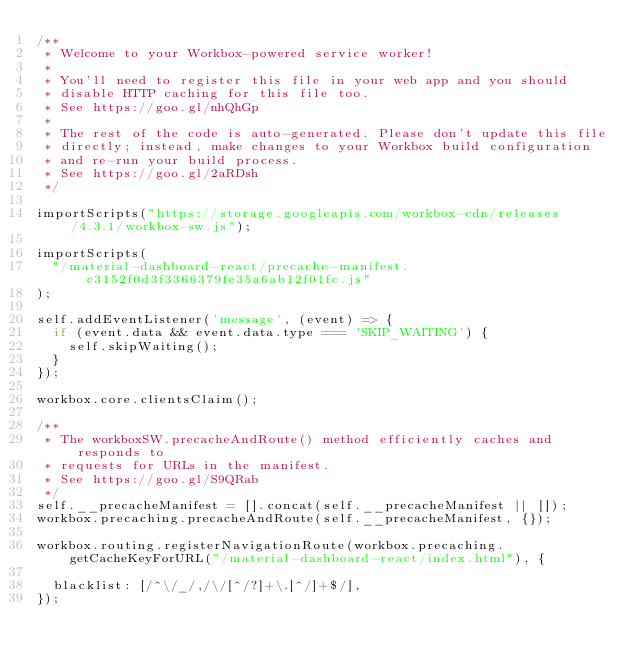<code> <loc_0><loc_0><loc_500><loc_500><_JavaScript_>/**
 * Welcome to your Workbox-powered service worker!
 *
 * You'll need to register this file in your web app and you should
 * disable HTTP caching for this file too.
 * See https://goo.gl/nhQhGp
 *
 * The rest of the code is auto-generated. Please don't update this file
 * directly; instead, make changes to your Workbox build configuration
 * and re-run your build process.
 * See https://goo.gl/2aRDsh
 */

importScripts("https://storage.googleapis.com/workbox-cdn/releases/4.3.1/workbox-sw.js");

importScripts(
  "/material-dashboard-react/precache-manifest.c3152f0d3f3366379fe35a6ab12f01fc.js"
);

self.addEventListener('message', (event) => {
  if (event.data && event.data.type === 'SKIP_WAITING') {
    self.skipWaiting();
  }
});

workbox.core.clientsClaim();

/**
 * The workboxSW.precacheAndRoute() method efficiently caches and responds to
 * requests for URLs in the manifest.
 * See https://goo.gl/S9QRab
 */
self.__precacheManifest = [].concat(self.__precacheManifest || []);
workbox.precaching.precacheAndRoute(self.__precacheManifest, {});

workbox.routing.registerNavigationRoute(workbox.precaching.getCacheKeyForURL("/material-dashboard-react/index.html"), {
  
  blacklist: [/^\/_/,/\/[^/?]+\.[^/]+$/],
});
</code> 